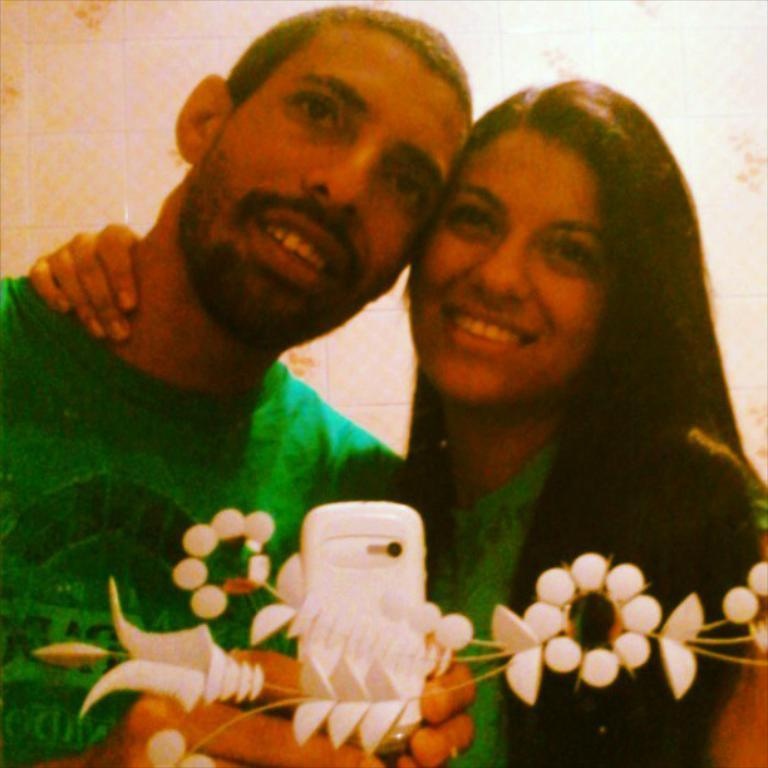What is the man in the image wearing? The man in the image is wearing a green t-shirt. What is the woman in the image doing? The woman is standing in front of a mirror and taking a picture using a cell phone. How is the woman feeling in the image? The woman is smiling, which suggests she is feeling happy or content. What month is it in the image? The month is not mentioned or visible in the image, so it cannot be determined. What type of magic is the woman performing in the image? There is no magic or any indication of magical activity in the image. 